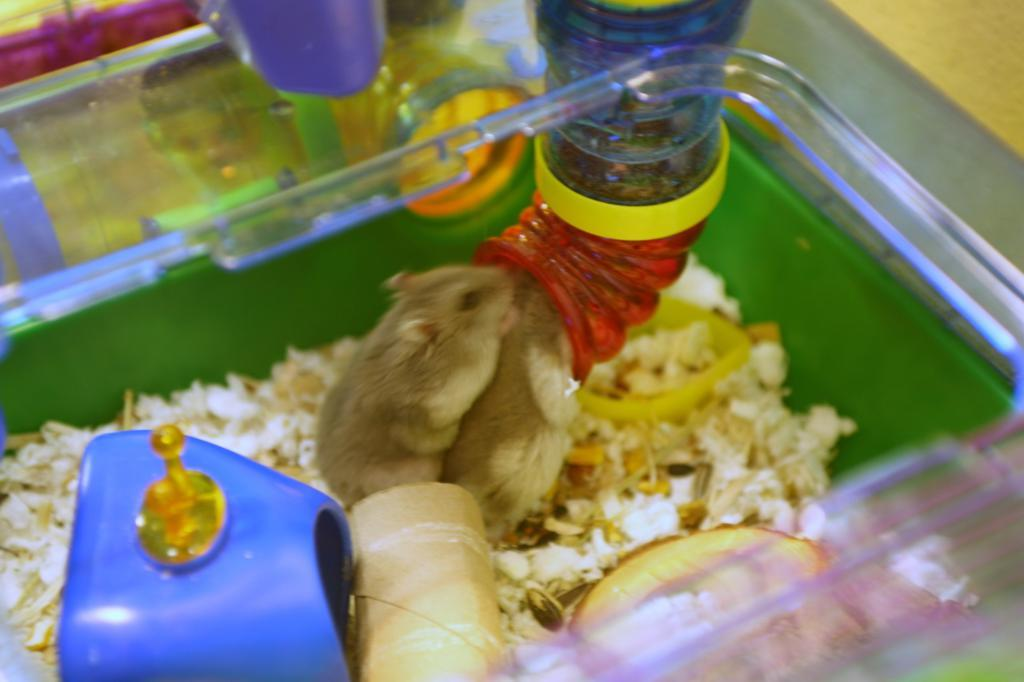What is the main object in the image? There is a plastic container in the image. What can be found inside the container? There are objects inside the container. What animals are present in the image? There are rats in the image. What other object can be seen in the image? There is a pipe in the image. Where is the land located in the image? There is no land present in the image. What type of watch is the rat wearing in the image? There are no watches present in the image, and the rats are not wearing any accessories. 